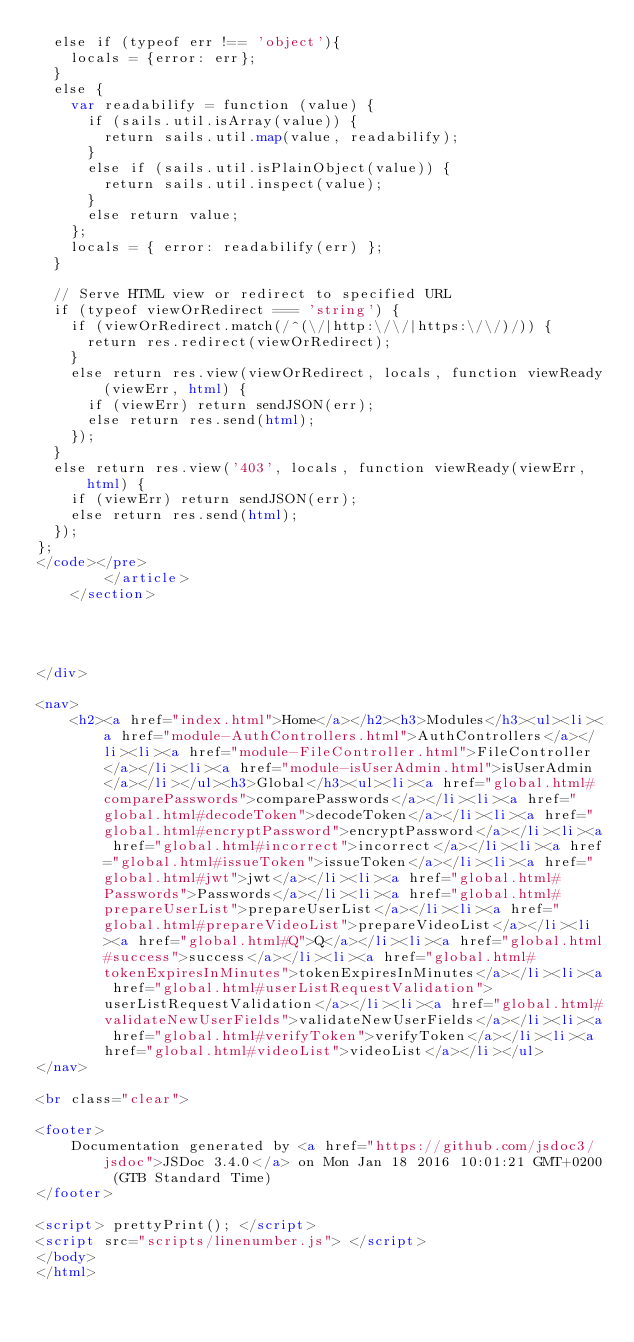<code> <loc_0><loc_0><loc_500><loc_500><_HTML_>  else if (typeof err !== 'object'){
    locals = {error: err};
  }
  else {
    var readabilify = function (value) {
      if (sails.util.isArray(value)) {
        return sails.util.map(value, readabilify);
      }
      else if (sails.util.isPlainObject(value)) {
        return sails.util.inspect(value);
      }
      else return value;
    };
    locals = { error: readabilify(err) };
  }

  // Serve HTML view or redirect to specified URL
  if (typeof viewOrRedirect === 'string') {
    if (viewOrRedirect.match(/^(\/|http:\/\/|https:\/\/)/)) {
      return res.redirect(viewOrRedirect);
    }
    else return res.view(viewOrRedirect, locals, function viewReady(viewErr, html) {
      if (viewErr) return sendJSON(err);
      else return res.send(html);
    });
  }
  else return res.view('403', locals, function viewReady(viewErr, html) {
    if (viewErr) return sendJSON(err);
    else return res.send(html);
  });
};
</code></pre>
        </article>
    </section>




</div>

<nav>
    <h2><a href="index.html">Home</a></h2><h3>Modules</h3><ul><li><a href="module-AuthControllers.html">AuthControllers</a></li><li><a href="module-FileController.html">FileController</a></li><li><a href="module-isUserAdmin.html">isUserAdmin</a></li></ul><h3>Global</h3><ul><li><a href="global.html#comparePasswords">comparePasswords</a></li><li><a href="global.html#decodeToken">decodeToken</a></li><li><a href="global.html#encryptPassword">encryptPassword</a></li><li><a href="global.html#incorrect">incorrect</a></li><li><a href="global.html#issueToken">issueToken</a></li><li><a href="global.html#jwt">jwt</a></li><li><a href="global.html#Passwords">Passwords</a></li><li><a href="global.html#prepareUserList">prepareUserList</a></li><li><a href="global.html#prepareVideoList">prepareVideoList</a></li><li><a href="global.html#Q">Q</a></li><li><a href="global.html#success">success</a></li><li><a href="global.html#tokenExpiresInMinutes">tokenExpiresInMinutes</a></li><li><a href="global.html#userListRequestValidation">userListRequestValidation</a></li><li><a href="global.html#validateNewUserFields">validateNewUserFields</a></li><li><a href="global.html#verifyToken">verifyToken</a></li><li><a href="global.html#videoList">videoList</a></li></ul>
</nav>

<br class="clear">

<footer>
    Documentation generated by <a href="https://github.com/jsdoc3/jsdoc">JSDoc 3.4.0</a> on Mon Jan 18 2016 10:01:21 GMT+0200 (GTB Standard Time)
</footer>

<script> prettyPrint(); </script>
<script src="scripts/linenumber.js"> </script>
</body>
</html>
</code> 